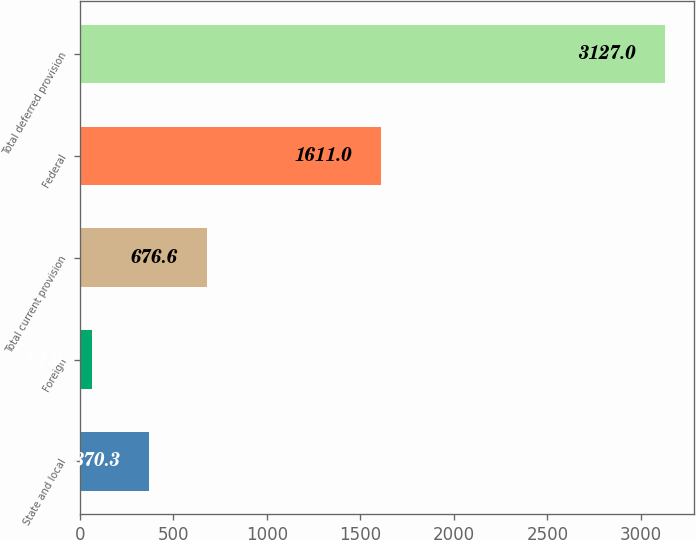<chart> <loc_0><loc_0><loc_500><loc_500><bar_chart><fcel>State and local<fcel>Foreign<fcel>Total current provision<fcel>Federal<fcel>Total deferred provision<nl><fcel>370.3<fcel>64<fcel>676.6<fcel>1611<fcel>3127<nl></chart> 